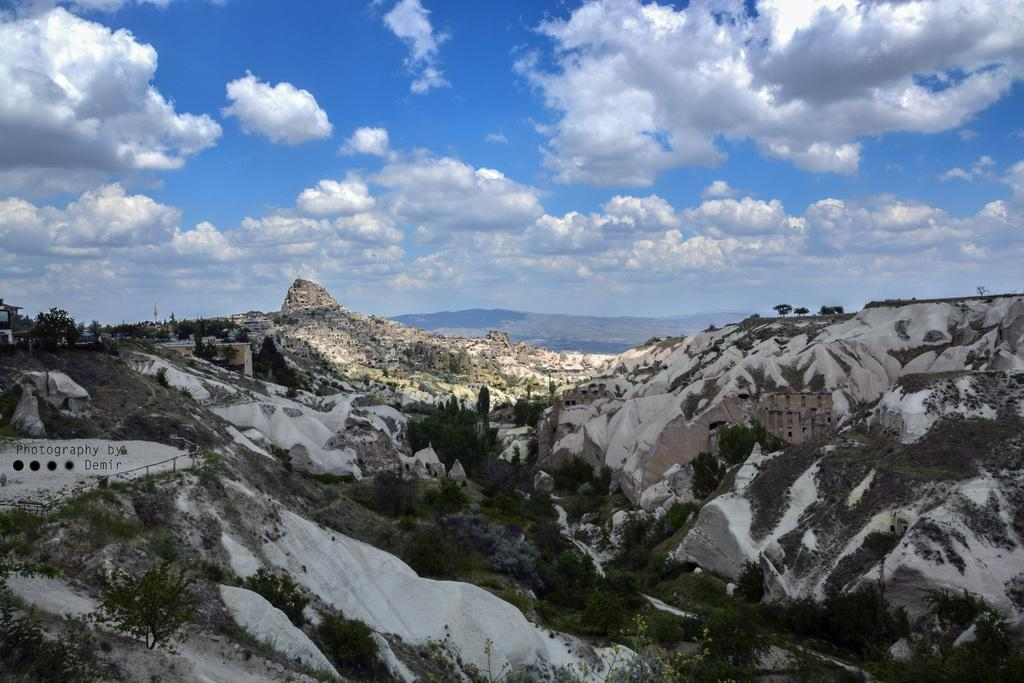What type of natural landscape can be seen in the image? There are hills in the image. What other elements are present in the image besides the hills? There are plants, pillars, sculptures, buildings, trees, and the sky visible in the image. Can you describe the sky in the image? The sky is visible in the image, and there are clouds present. How many cars are parked near the sculptures in the image? There are no cars present in the image; it only features hills, plants, pillars, sculptures, buildings, trees, and the sky. 